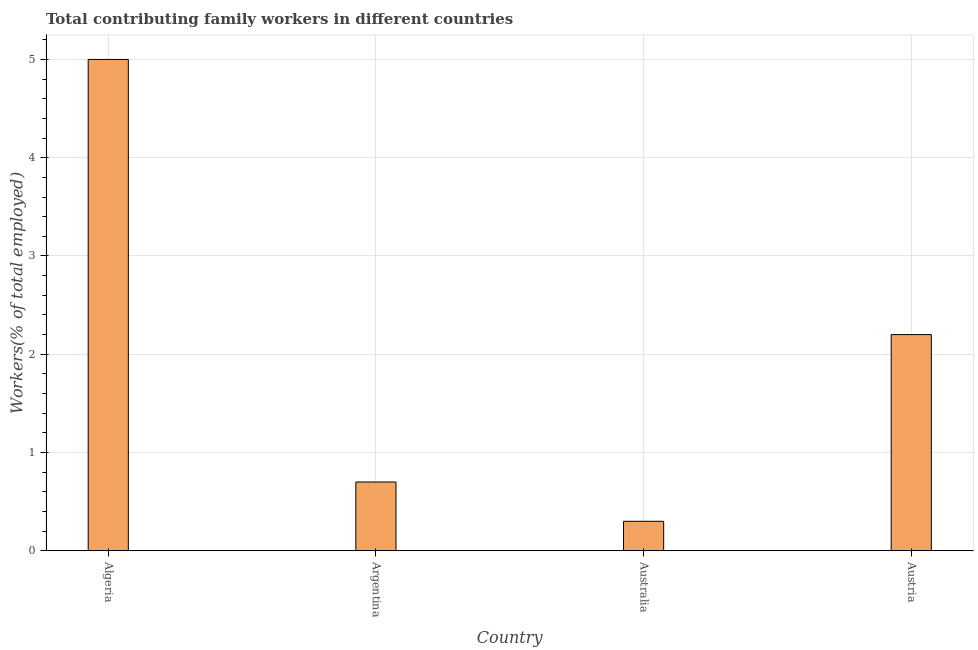Does the graph contain grids?
Offer a terse response. Yes. What is the title of the graph?
Give a very brief answer. Total contributing family workers in different countries. What is the label or title of the X-axis?
Offer a very short reply. Country. What is the label or title of the Y-axis?
Offer a very short reply. Workers(% of total employed). What is the contributing family workers in Austria?
Ensure brevity in your answer.  2.2. Across all countries, what is the maximum contributing family workers?
Provide a succinct answer. 5. Across all countries, what is the minimum contributing family workers?
Keep it short and to the point. 0.3. In which country was the contributing family workers maximum?
Ensure brevity in your answer.  Algeria. In which country was the contributing family workers minimum?
Provide a succinct answer. Australia. What is the sum of the contributing family workers?
Keep it short and to the point. 8.2. What is the difference between the contributing family workers in Algeria and Australia?
Provide a succinct answer. 4.7. What is the average contributing family workers per country?
Keep it short and to the point. 2.05. What is the median contributing family workers?
Offer a terse response. 1.45. What is the ratio of the contributing family workers in Argentina to that in Australia?
Provide a short and direct response. 2.33. Is the contributing family workers in Argentina less than that in Austria?
Ensure brevity in your answer.  Yes. Is the sum of the contributing family workers in Argentina and Australia greater than the maximum contributing family workers across all countries?
Give a very brief answer. No. What is the difference between the highest and the lowest contributing family workers?
Give a very brief answer. 4.7. How many bars are there?
Ensure brevity in your answer.  4. How many countries are there in the graph?
Make the answer very short. 4. What is the difference between two consecutive major ticks on the Y-axis?
Your answer should be compact. 1. Are the values on the major ticks of Y-axis written in scientific E-notation?
Your response must be concise. No. What is the Workers(% of total employed) in Argentina?
Make the answer very short. 0.7. What is the Workers(% of total employed) in Australia?
Offer a very short reply. 0.3. What is the Workers(% of total employed) in Austria?
Give a very brief answer. 2.2. What is the difference between the Workers(% of total employed) in Argentina and Australia?
Offer a very short reply. 0.4. What is the difference between the Workers(% of total employed) in Argentina and Austria?
Offer a very short reply. -1.5. What is the ratio of the Workers(% of total employed) in Algeria to that in Argentina?
Ensure brevity in your answer.  7.14. What is the ratio of the Workers(% of total employed) in Algeria to that in Australia?
Your answer should be very brief. 16.67. What is the ratio of the Workers(% of total employed) in Algeria to that in Austria?
Offer a very short reply. 2.27. What is the ratio of the Workers(% of total employed) in Argentina to that in Australia?
Your response must be concise. 2.33. What is the ratio of the Workers(% of total employed) in Argentina to that in Austria?
Provide a succinct answer. 0.32. What is the ratio of the Workers(% of total employed) in Australia to that in Austria?
Offer a very short reply. 0.14. 